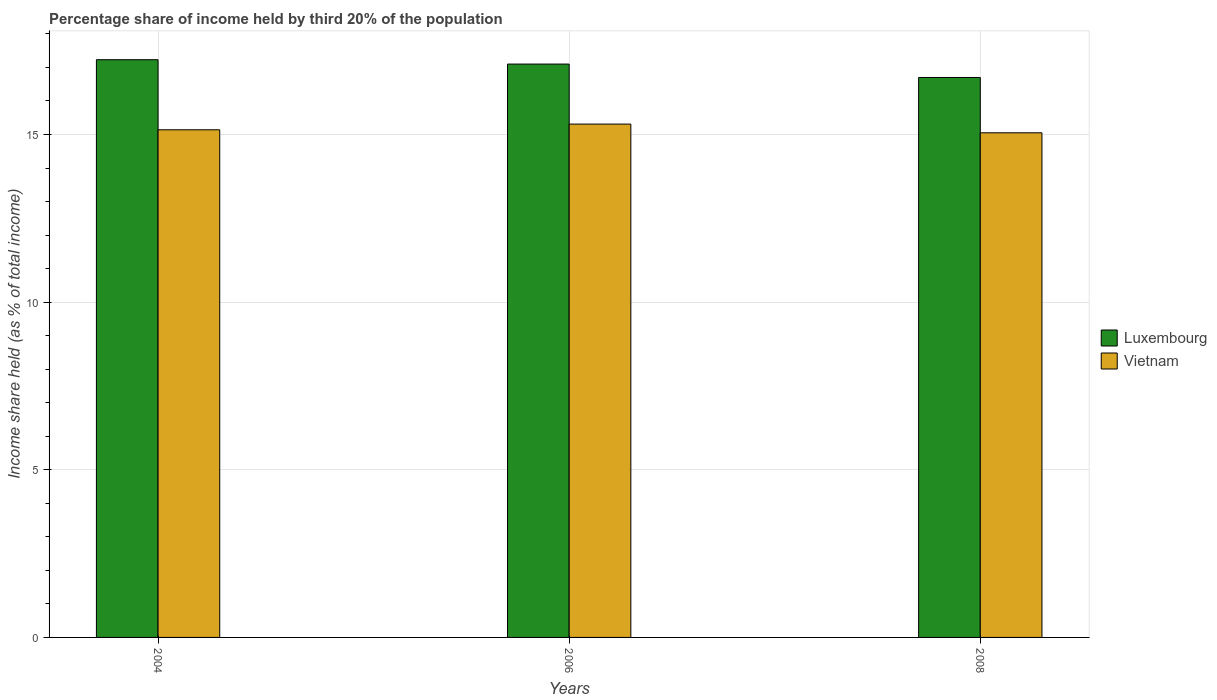How many groups of bars are there?
Provide a short and direct response. 3. Are the number of bars per tick equal to the number of legend labels?
Your answer should be very brief. Yes. Are the number of bars on each tick of the X-axis equal?
Your response must be concise. Yes. How many bars are there on the 1st tick from the left?
Provide a succinct answer. 2. What is the label of the 1st group of bars from the left?
Your answer should be compact. 2004. In how many cases, is the number of bars for a given year not equal to the number of legend labels?
Provide a short and direct response. 0. What is the share of income held by third 20% of the population in Vietnam in 2008?
Ensure brevity in your answer.  15.05. Across all years, what is the maximum share of income held by third 20% of the population in Vietnam?
Your response must be concise. 15.31. Across all years, what is the minimum share of income held by third 20% of the population in Vietnam?
Provide a short and direct response. 15.05. What is the total share of income held by third 20% of the population in Luxembourg in the graph?
Keep it short and to the point. 51.03. What is the difference between the share of income held by third 20% of the population in Vietnam in 2004 and that in 2008?
Your answer should be compact. 0.09. What is the difference between the share of income held by third 20% of the population in Vietnam in 2008 and the share of income held by third 20% of the population in Luxembourg in 2006?
Make the answer very short. -2.05. What is the average share of income held by third 20% of the population in Vietnam per year?
Your answer should be compact. 15.17. In the year 2008, what is the difference between the share of income held by third 20% of the population in Vietnam and share of income held by third 20% of the population in Luxembourg?
Provide a short and direct response. -1.65. In how many years, is the share of income held by third 20% of the population in Luxembourg greater than 15 %?
Provide a succinct answer. 3. What is the ratio of the share of income held by third 20% of the population in Luxembourg in 2004 to that in 2008?
Your answer should be compact. 1.03. Is the share of income held by third 20% of the population in Vietnam in 2004 less than that in 2006?
Offer a terse response. Yes. Is the difference between the share of income held by third 20% of the population in Vietnam in 2004 and 2006 greater than the difference between the share of income held by third 20% of the population in Luxembourg in 2004 and 2006?
Provide a short and direct response. No. What is the difference between the highest and the second highest share of income held by third 20% of the population in Luxembourg?
Offer a very short reply. 0.13. What is the difference between the highest and the lowest share of income held by third 20% of the population in Luxembourg?
Provide a succinct answer. 0.53. In how many years, is the share of income held by third 20% of the population in Luxembourg greater than the average share of income held by third 20% of the population in Luxembourg taken over all years?
Offer a very short reply. 2. Is the sum of the share of income held by third 20% of the population in Vietnam in 2004 and 2008 greater than the maximum share of income held by third 20% of the population in Luxembourg across all years?
Your answer should be very brief. Yes. What does the 2nd bar from the left in 2006 represents?
Your answer should be compact. Vietnam. What does the 1st bar from the right in 2008 represents?
Your response must be concise. Vietnam. How many years are there in the graph?
Give a very brief answer. 3. What is the difference between two consecutive major ticks on the Y-axis?
Keep it short and to the point. 5. Are the values on the major ticks of Y-axis written in scientific E-notation?
Make the answer very short. No. Does the graph contain grids?
Ensure brevity in your answer.  Yes. What is the title of the graph?
Keep it short and to the point. Percentage share of income held by third 20% of the population. Does "Cyprus" appear as one of the legend labels in the graph?
Your answer should be very brief. No. What is the label or title of the X-axis?
Provide a succinct answer. Years. What is the label or title of the Y-axis?
Provide a succinct answer. Income share held (as % of total income). What is the Income share held (as % of total income) in Luxembourg in 2004?
Provide a short and direct response. 17.23. What is the Income share held (as % of total income) of Vietnam in 2004?
Give a very brief answer. 15.14. What is the Income share held (as % of total income) in Vietnam in 2006?
Ensure brevity in your answer.  15.31. What is the Income share held (as % of total income) in Vietnam in 2008?
Offer a terse response. 15.05. Across all years, what is the maximum Income share held (as % of total income) in Luxembourg?
Your answer should be compact. 17.23. Across all years, what is the maximum Income share held (as % of total income) of Vietnam?
Your response must be concise. 15.31. Across all years, what is the minimum Income share held (as % of total income) of Luxembourg?
Provide a short and direct response. 16.7. Across all years, what is the minimum Income share held (as % of total income) of Vietnam?
Keep it short and to the point. 15.05. What is the total Income share held (as % of total income) of Luxembourg in the graph?
Your answer should be compact. 51.03. What is the total Income share held (as % of total income) in Vietnam in the graph?
Ensure brevity in your answer.  45.5. What is the difference between the Income share held (as % of total income) in Luxembourg in 2004 and that in 2006?
Ensure brevity in your answer.  0.13. What is the difference between the Income share held (as % of total income) in Vietnam in 2004 and that in 2006?
Your answer should be very brief. -0.17. What is the difference between the Income share held (as % of total income) of Luxembourg in 2004 and that in 2008?
Your response must be concise. 0.53. What is the difference between the Income share held (as % of total income) of Vietnam in 2004 and that in 2008?
Keep it short and to the point. 0.09. What is the difference between the Income share held (as % of total income) in Vietnam in 2006 and that in 2008?
Keep it short and to the point. 0.26. What is the difference between the Income share held (as % of total income) in Luxembourg in 2004 and the Income share held (as % of total income) in Vietnam in 2006?
Provide a short and direct response. 1.92. What is the difference between the Income share held (as % of total income) in Luxembourg in 2004 and the Income share held (as % of total income) in Vietnam in 2008?
Provide a short and direct response. 2.18. What is the difference between the Income share held (as % of total income) in Luxembourg in 2006 and the Income share held (as % of total income) in Vietnam in 2008?
Keep it short and to the point. 2.05. What is the average Income share held (as % of total income) of Luxembourg per year?
Keep it short and to the point. 17.01. What is the average Income share held (as % of total income) in Vietnam per year?
Your answer should be compact. 15.17. In the year 2004, what is the difference between the Income share held (as % of total income) of Luxembourg and Income share held (as % of total income) of Vietnam?
Keep it short and to the point. 2.09. In the year 2006, what is the difference between the Income share held (as % of total income) in Luxembourg and Income share held (as % of total income) in Vietnam?
Give a very brief answer. 1.79. In the year 2008, what is the difference between the Income share held (as % of total income) in Luxembourg and Income share held (as % of total income) in Vietnam?
Make the answer very short. 1.65. What is the ratio of the Income share held (as % of total income) in Luxembourg in 2004 to that in 2006?
Your answer should be very brief. 1.01. What is the ratio of the Income share held (as % of total income) in Vietnam in 2004 to that in 2006?
Your answer should be compact. 0.99. What is the ratio of the Income share held (as % of total income) of Luxembourg in 2004 to that in 2008?
Provide a short and direct response. 1.03. What is the ratio of the Income share held (as % of total income) of Vietnam in 2006 to that in 2008?
Make the answer very short. 1.02. What is the difference between the highest and the second highest Income share held (as % of total income) in Luxembourg?
Your answer should be very brief. 0.13. What is the difference between the highest and the second highest Income share held (as % of total income) of Vietnam?
Ensure brevity in your answer.  0.17. What is the difference between the highest and the lowest Income share held (as % of total income) of Luxembourg?
Offer a very short reply. 0.53. What is the difference between the highest and the lowest Income share held (as % of total income) in Vietnam?
Your response must be concise. 0.26. 